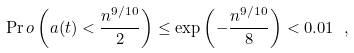<formula> <loc_0><loc_0><loc_500><loc_500>\Pr o \left ( a ( t ) < \frac { n ^ { 9 / 1 0 } } { 2 } \right ) \leq \exp \left ( - \frac { n ^ { 9 / 1 0 } } { 8 } \right ) < 0 . 0 1 \ ,</formula> 